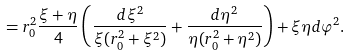Convert formula to latex. <formula><loc_0><loc_0><loc_500><loc_500>= r _ { 0 } ^ { 2 } \frac { \xi + \eta } { 4 } \left ( \frac { d \xi ^ { 2 } } { \xi ( r _ { 0 } ^ { 2 } + \xi ^ { 2 } ) } + \frac { d \eta ^ { 2 } } { \eta ( r ^ { 2 } _ { 0 } + \eta ^ { 2 } ) } \right ) + \xi \eta d \varphi ^ { 2 } .</formula> 